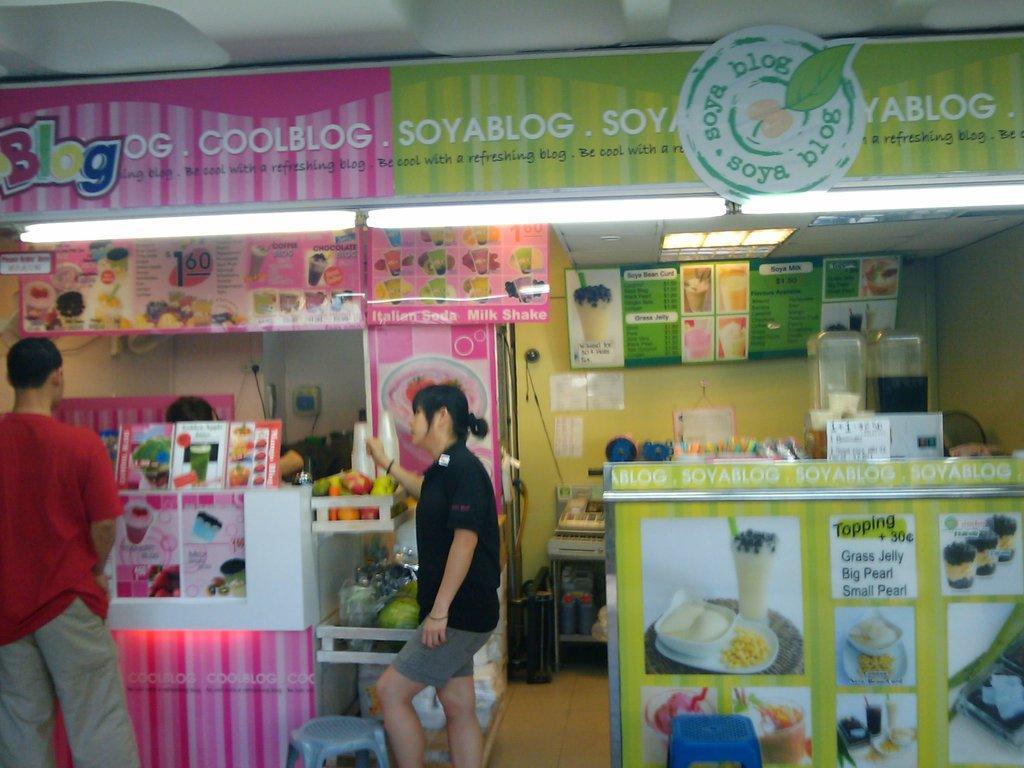In one or two sentences, can you explain what this image depicts? In this image, on the left side, we can see a man wearing a red color shirt is standing in front of the stall. In the middle of the image, we can also see a woman wearing a black color shirt is standing in front of the table. In the background, we can see a stall, fruits, juices. In the background, we can also see a person standing in front of the stall. In the background, we can also see a board with some pictures and text on it. At the top, we can see a roof. 